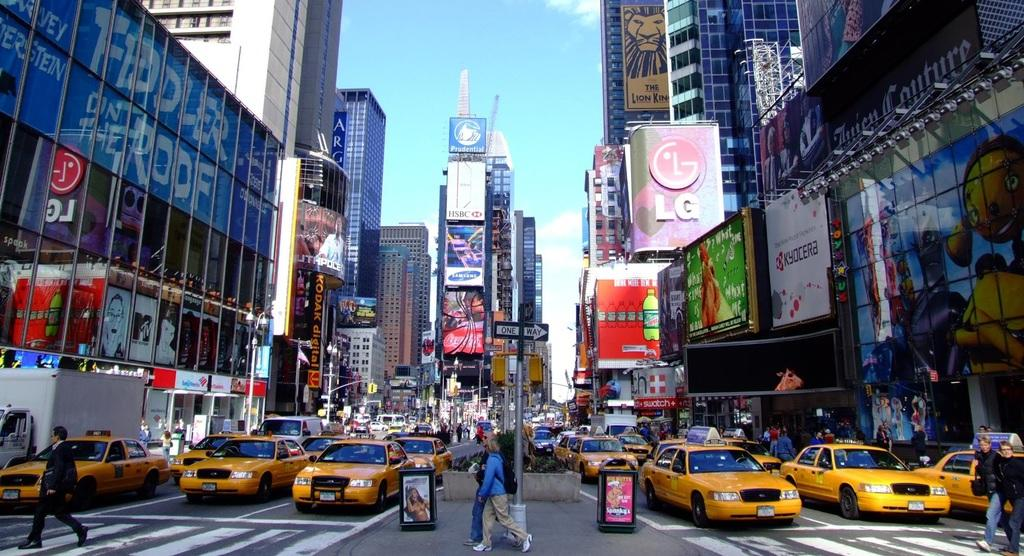Provide a one-sentence caption for the provided image. Many taxis driving in a busy city with advertisements everywhere including one for LG. 